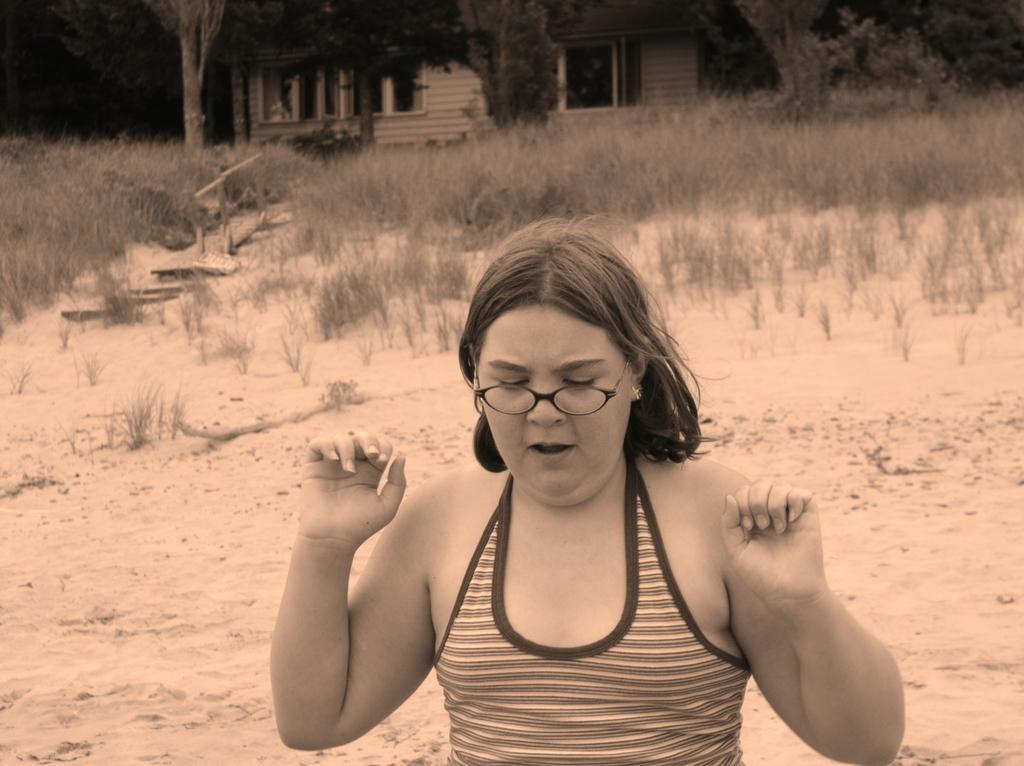Please provide a concise description of this image. This image consists of a woman. At the bottom, there is ground. And we can see the plants on the ground. In the background, there are trees. 